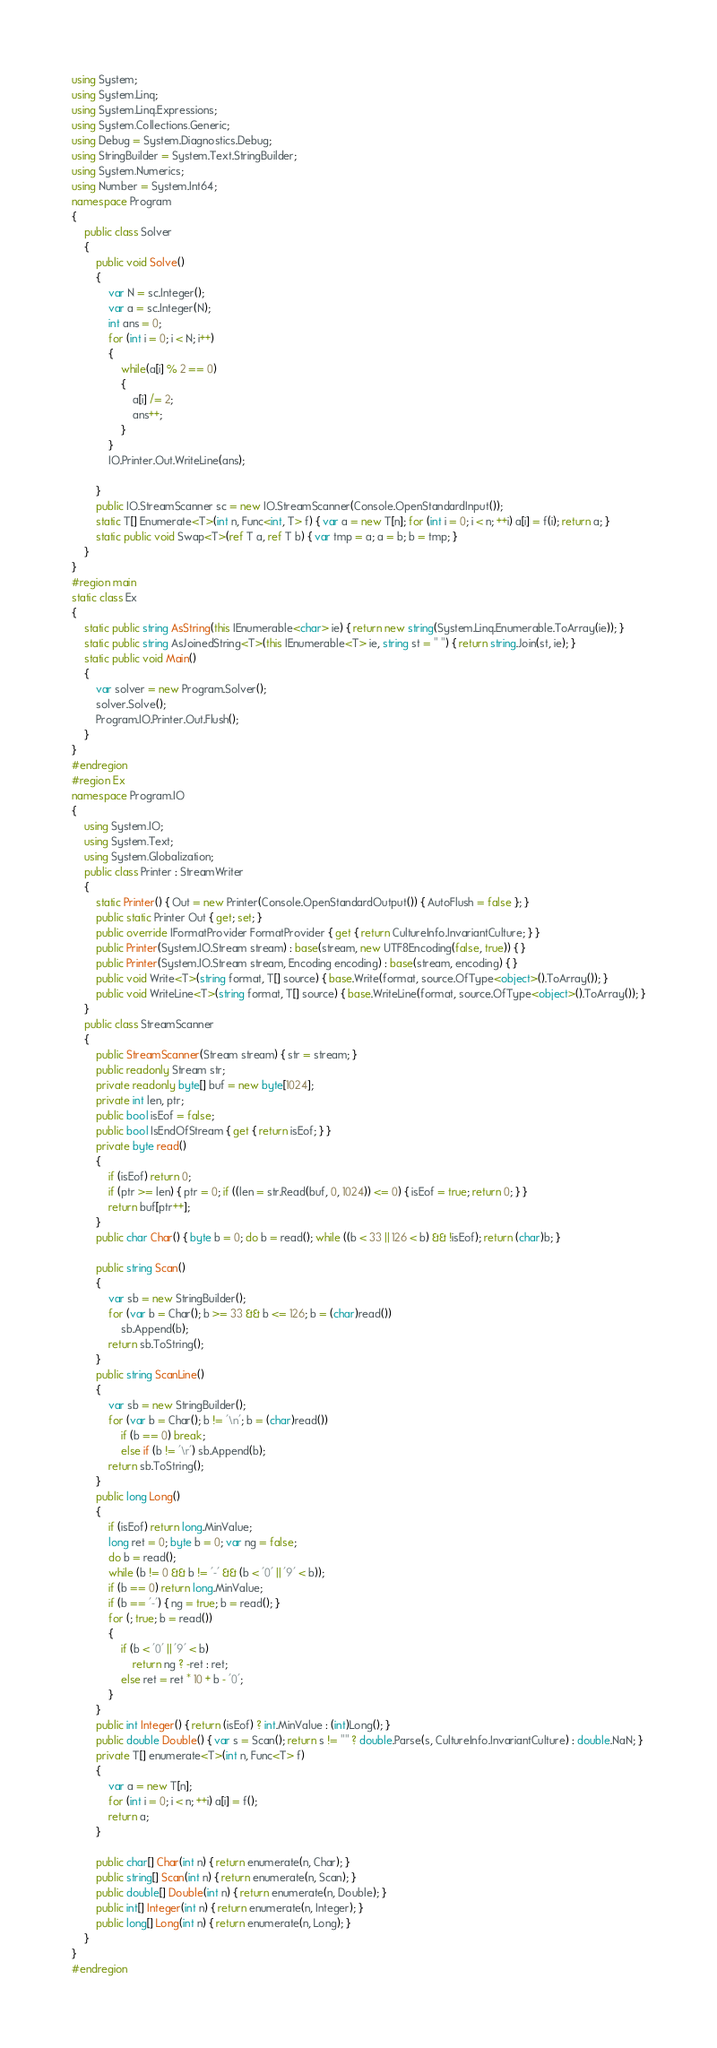Convert code to text. <code><loc_0><loc_0><loc_500><loc_500><_C#_>using System;
using System.Linq;
using System.Linq.Expressions;
using System.Collections.Generic;
using Debug = System.Diagnostics.Debug;
using StringBuilder = System.Text.StringBuilder;
using System.Numerics;
using Number = System.Int64;
namespace Program
{
    public class Solver
    {
        public void Solve()
        {
            var N = sc.Integer();
            var a = sc.Integer(N);
            int ans = 0;
            for (int i = 0; i < N; i++)
            {
                while(a[i] % 2 == 0)
                {
                    a[i] /= 2;
                    ans++;
                }
            }
            IO.Printer.Out.WriteLine(ans);
            
        }
        public IO.StreamScanner sc = new IO.StreamScanner(Console.OpenStandardInput());
        static T[] Enumerate<T>(int n, Func<int, T> f) { var a = new T[n]; for (int i = 0; i < n; ++i) a[i] = f(i); return a; }
        static public void Swap<T>(ref T a, ref T b) { var tmp = a; a = b; b = tmp; }
    }
}
#region main
static class Ex
{
    static public string AsString(this IEnumerable<char> ie) { return new string(System.Linq.Enumerable.ToArray(ie)); }
    static public string AsJoinedString<T>(this IEnumerable<T> ie, string st = " ") { return string.Join(st, ie); }
    static public void Main()
    {
        var solver = new Program.Solver();
        solver.Solve();
        Program.IO.Printer.Out.Flush();
    }
}
#endregion
#region Ex
namespace Program.IO
{
    using System.IO;
    using System.Text;
    using System.Globalization;
    public class Printer : StreamWriter
    {
        static Printer() { Out = new Printer(Console.OpenStandardOutput()) { AutoFlush = false }; }
        public static Printer Out { get; set; }
        public override IFormatProvider FormatProvider { get { return CultureInfo.InvariantCulture; } }
        public Printer(System.IO.Stream stream) : base(stream, new UTF8Encoding(false, true)) { }
        public Printer(System.IO.Stream stream, Encoding encoding) : base(stream, encoding) { }
        public void Write<T>(string format, T[] source) { base.Write(format, source.OfType<object>().ToArray()); }
        public void WriteLine<T>(string format, T[] source) { base.WriteLine(format, source.OfType<object>().ToArray()); }
    }
    public class StreamScanner
    {
        public StreamScanner(Stream stream) { str = stream; }
        public readonly Stream str;
        private readonly byte[] buf = new byte[1024];
        private int len, ptr;
        public bool isEof = false;
        public bool IsEndOfStream { get { return isEof; } }
        private byte read()
        {
            if (isEof) return 0;
            if (ptr >= len) { ptr = 0; if ((len = str.Read(buf, 0, 1024)) <= 0) { isEof = true; return 0; } }
            return buf[ptr++];
        }
        public char Char() { byte b = 0; do b = read(); while ((b < 33 || 126 < b) && !isEof); return (char)b; }

        public string Scan()
        {
            var sb = new StringBuilder();
            for (var b = Char(); b >= 33 && b <= 126; b = (char)read())
                sb.Append(b);
            return sb.ToString();
        }
        public string ScanLine()
        {
            var sb = new StringBuilder();
            for (var b = Char(); b != '\n'; b = (char)read())
                if (b == 0) break;
                else if (b != '\r') sb.Append(b);
            return sb.ToString();
        }
        public long Long()
        {
            if (isEof) return long.MinValue;
            long ret = 0; byte b = 0; var ng = false;
            do b = read();
            while (b != 0 && b != '-' && (b < '0' || '9' < b));
            if (b == 0) return long.MinValue;
            if (b == '-') { ng = true; b = read(); }
            for (; true; b = read())
            {
                if (b < '0' || '9' < b)
                    return ng ? -ret : ret;
                else ret = ret * 10 + b - '0';
            }
        }
        public int Integer() { return (isEof) ? int.MinValue : (int)Long(); }
        public double Double() { var s = Scan(); return s != "" ? double.Parse(s, CultureInfo.InvariantCulture) : double.NaN; }
        private T[] enumerate<T>(int n, Func<T> f)
        {
            var a = new T[n];
            for (int i = 0; i < n; ++i) a[i] = f();
            return a;
        }

        public char[] Char(int n) { return enumerate(n, Char); }
        public string[] Scan(int n) { return enumerate(n, Scan); }
        public double[] Double(int n) { return enumerate(n, Double); }
        public int[] Integer(int n) { return enumerate(n, Integer); }
        public long[] Long(int n) { return enumerate(n, Long); }
    }
}
#endregion
</code> 